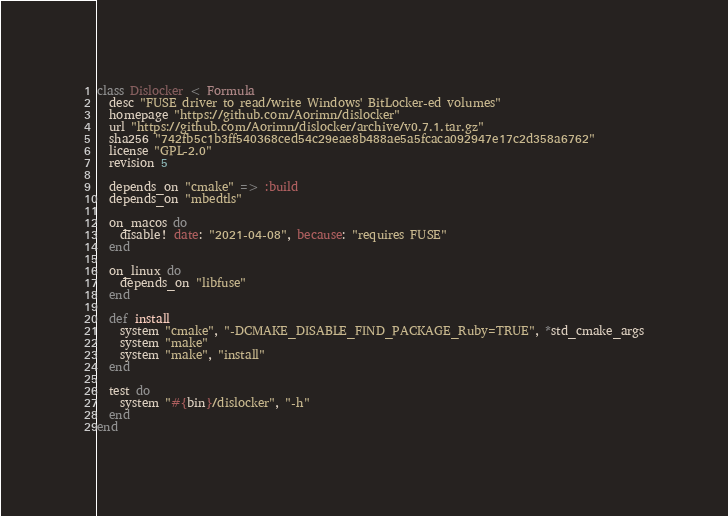<code> <loc_0><loc_0><loc_500><loc_500><_Ruby_>class Dislocker < Formula
  desc "FUSE driver to read/write Windows' BitLocker-ed volumes"
  homepage "https://github.com/Aorimn/dislocker"
  url "https://github.com/Aorimn/dislocker/archive/v0.7.1.tar.gz"
  sha256 "742fb5c1b3ff540368ced54c29eae8b488ae5a5fcaca092947e17c2d358a6762"
  license "GPL-2.0"
  revision 5

  depends_on "cmake" => :build
  depends_on "mbedtls"

  on_macos do
    disable! date: "2021-04-08", because: "requires FUSE"
  end

  on_linux do
    depends_on "libfuse"
  end

  def install
    system "cmake", "-DCMAKE_DISABLE_FIND_PACKAGE_Ruby=TRUE", *std_cmake_args
    system "make"
    system "make", "install"
  end

  test do
    system "#{bin}/dislocker", "-h"
  end
end
</code> 